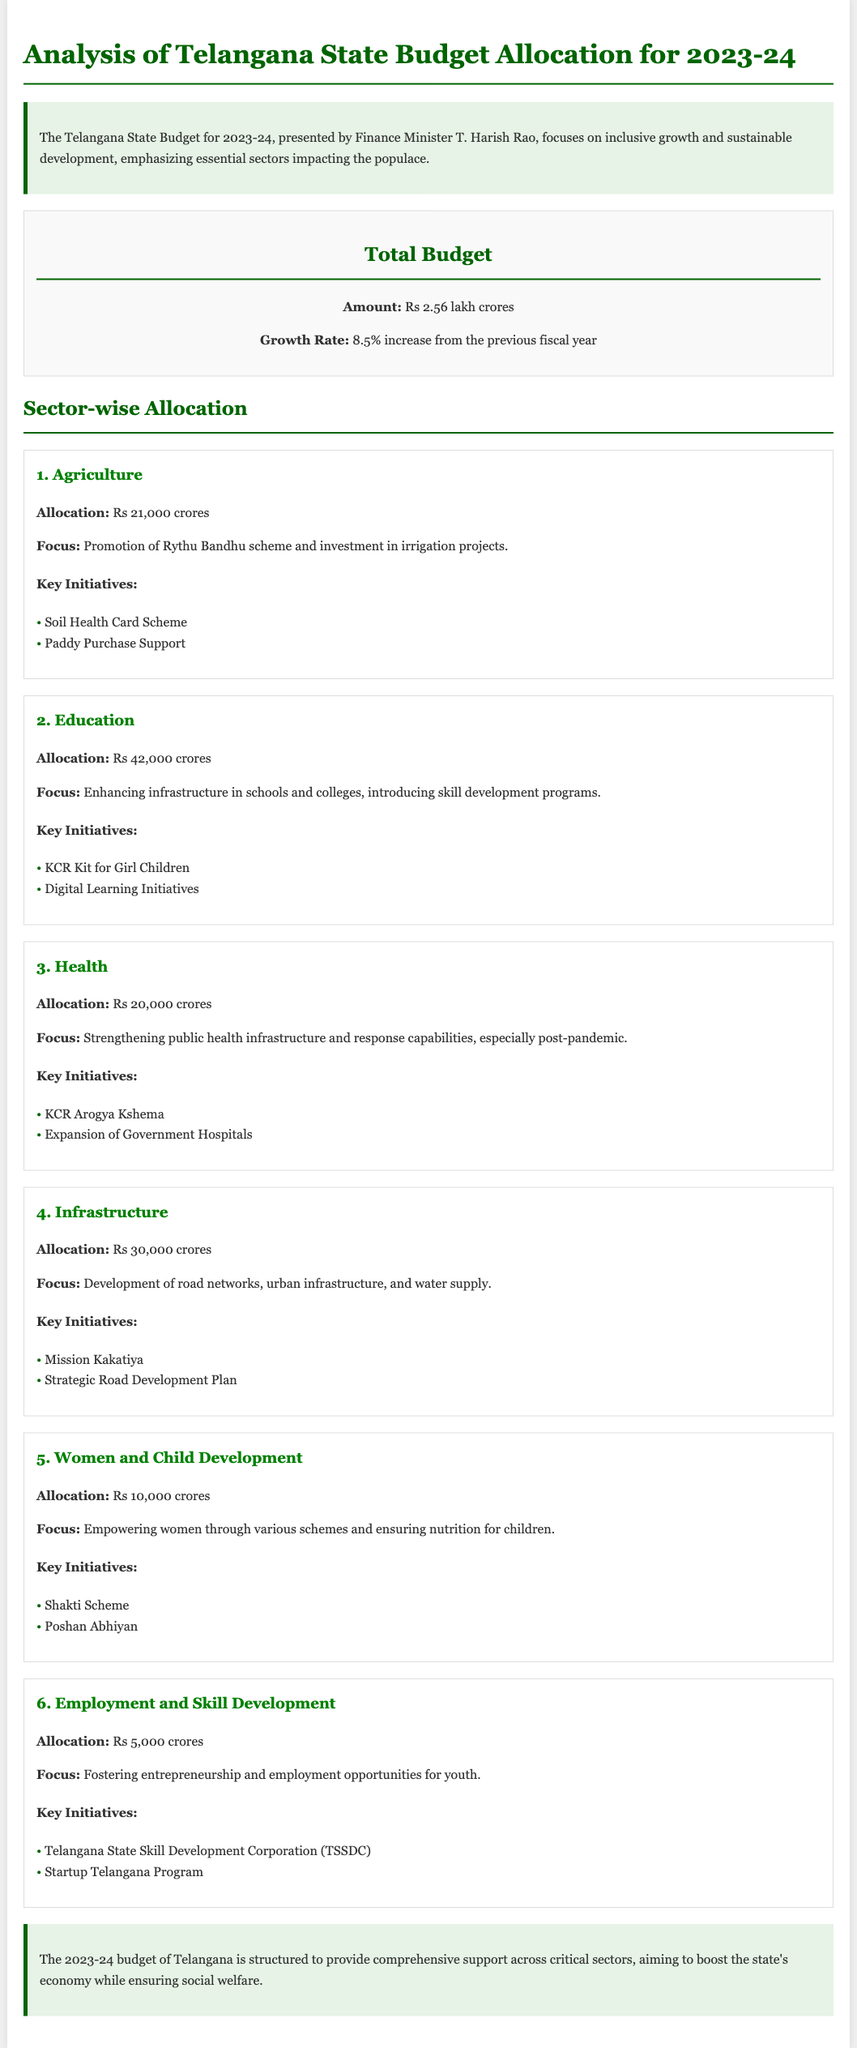What is the total budget allocation for Telangana for 2023-24? The total budget allocation is provided in the document, stating an amount of Rs 2.56 lakh crores.
Answer: Rs 2.56 lakh crores What is the growth rate of the budget from the previous fiscal year? The document highlights that the budget has an increase of 8.5% from the previous fiscal year.
Answer: 8.5% How much is allocated to the Education sector? The document specifies the allocation for the Education sector as Rs 42,000 crores.
Answer: Rs 42,000 crores What key initiative is associated with the Women and Child Development sector? The document lists key initiatives under the Women and Child Development sector, including the Shakti Scheme.
Answer: Shakti Scheme Which sector has the highest budget allocation in Telangana's budget? The document details sector-wise allocations, indicating that the Education sector has the highest allocation with Rs 42,000 crores.
Answer: Education What is the focus of the Health sector allocation? The document describes the focus for the Health sector as strengthening public health infrastructure and response capabilities, especially post-pandemic.
Answer: Strengthening public health infrastructure What is the allocation for Employment and Skill Development? The document specifies an allocation of Rs 5,000 crores for Employment and Skill Development.
Answer: Rs 5,000 crores How many key initiatives are mentioned in the Infrastructure sector? The Infrastructure sector has two key initiatives mentioned in the document: Mission Kakatiya and Strategic Road Development Plan.
Answer: Two What is one key focus area of the Agriculture budget? The document emphasizes that a focus area of the Agriculture budget includes the promotion of the Rythu Bandhu scheme.
Answer: Rythu Bandhu scheme 